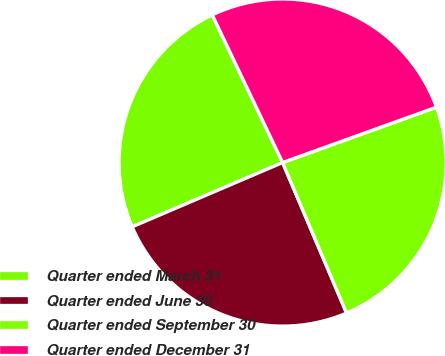<chart> <loc_0><loc_0><loc_500><loc_500><pie_chart><fcel>Quarter ended March 31<fcel>Quarter ended June 30<fcel>Quarter ended September 30<fcel>Quarter ended December 31<nl><fcel>24.35%<fcel>24.97%<fcel>24.1%<fcel>26.58%<nl></chart> 